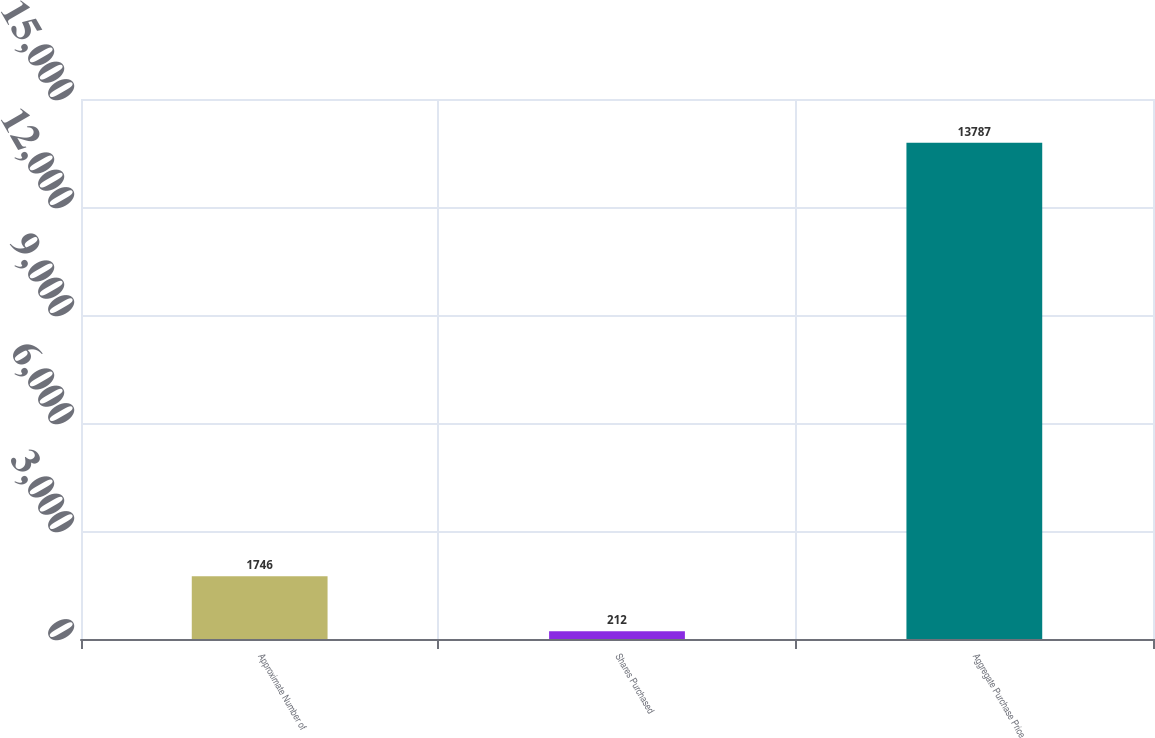<chart> <loc_0><loc_0><loc_500><loc_500><bar_chart><fcel>Approximate Number of<fcel>Shares Purchased<fcel>Aggregate Purchase Price<nl><fcel>1746<fcel>212<fcel>13787<nl></chart> 